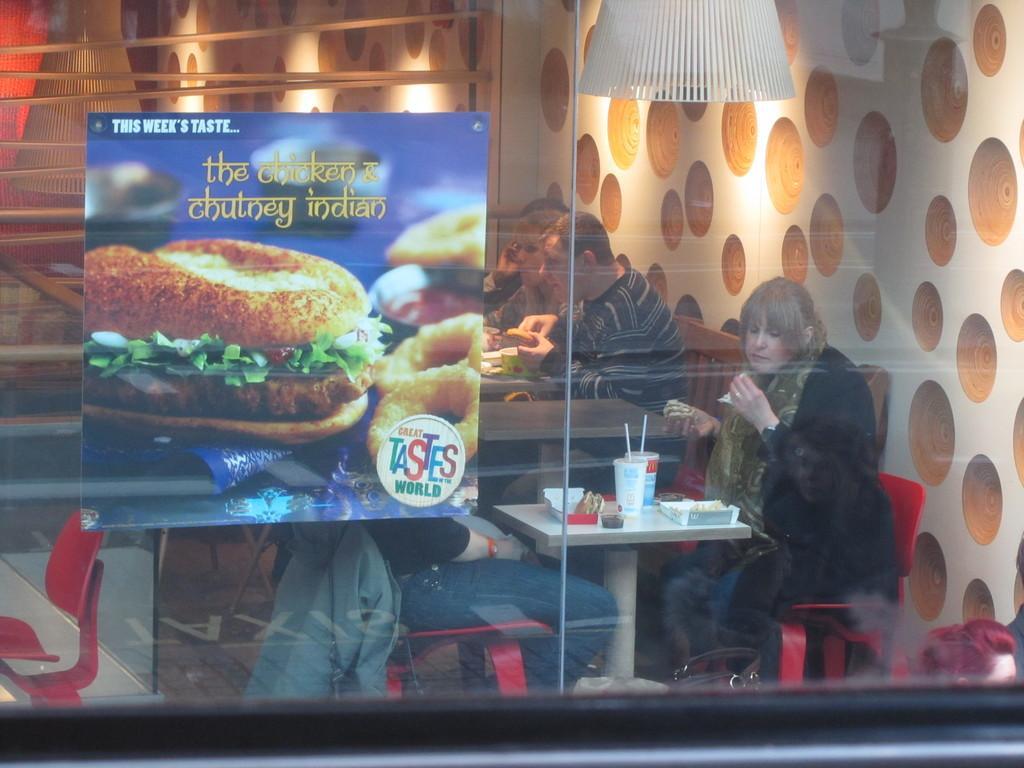Describe this image in one or two sentences. We can see poster over a glass. Through glass we can see persons sitting on chairs in front of a table and having food. On the table we can see boxes, g;lasses with straws. 